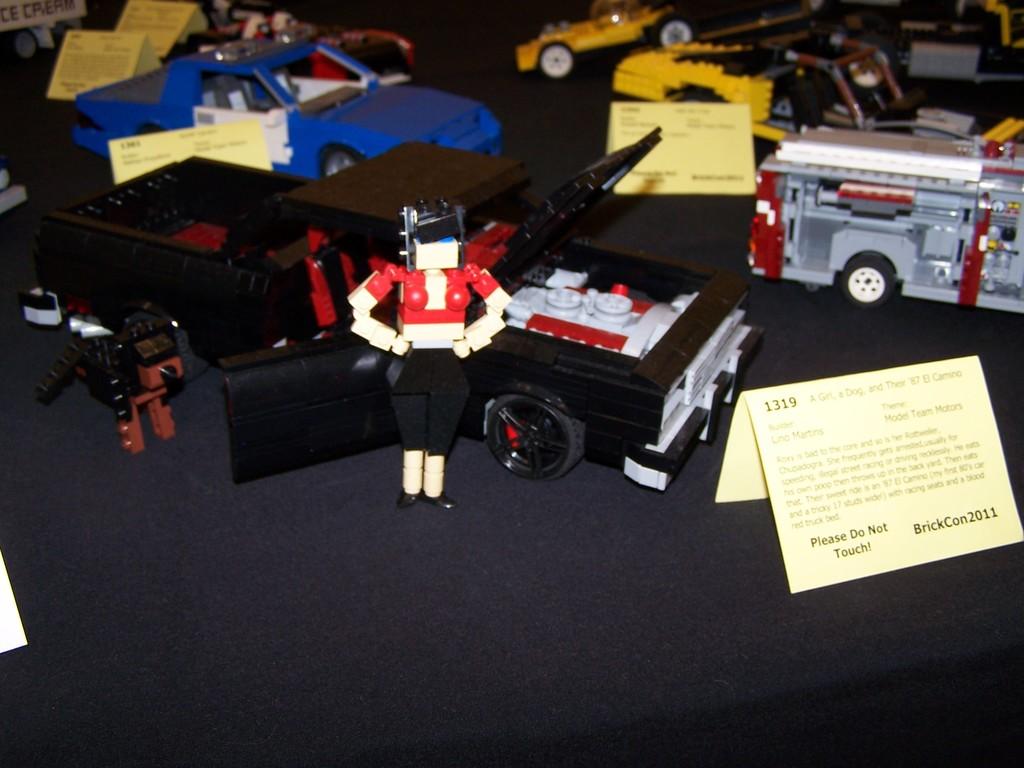What year was this display shown at brick con?
Your answer should be compact. 2011. 